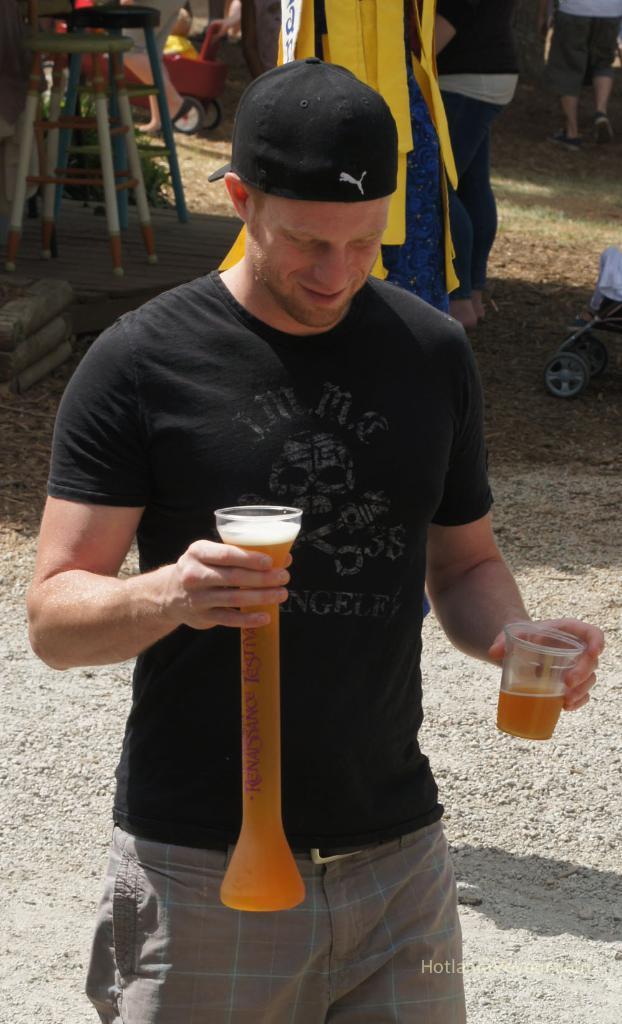Please provide a concise description of this image. In the picture we can see a man standing on the ground surface and he is holding a tube with a liquid in it and a glass in the other hand and he is with black T-shirt and cap and behind him we can see some stools and some things are placed on the ground. 